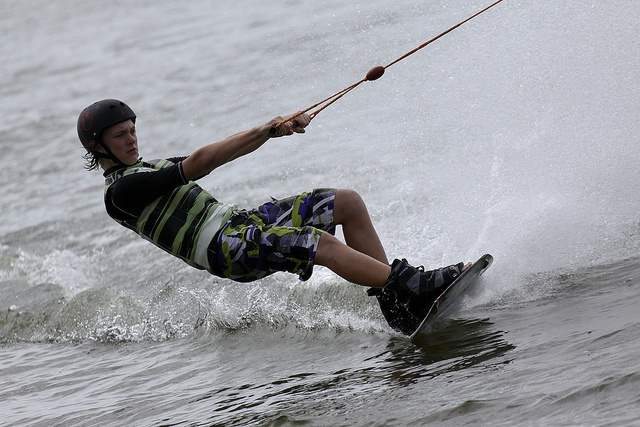Describe the objects in this image and their specific colors. I can see people in darkgray, black, gray, and lightgray tones, surfboard in darkgray, black, and gray tones, and snowboard in darkgray, black, gray, and purple tones in this image. 